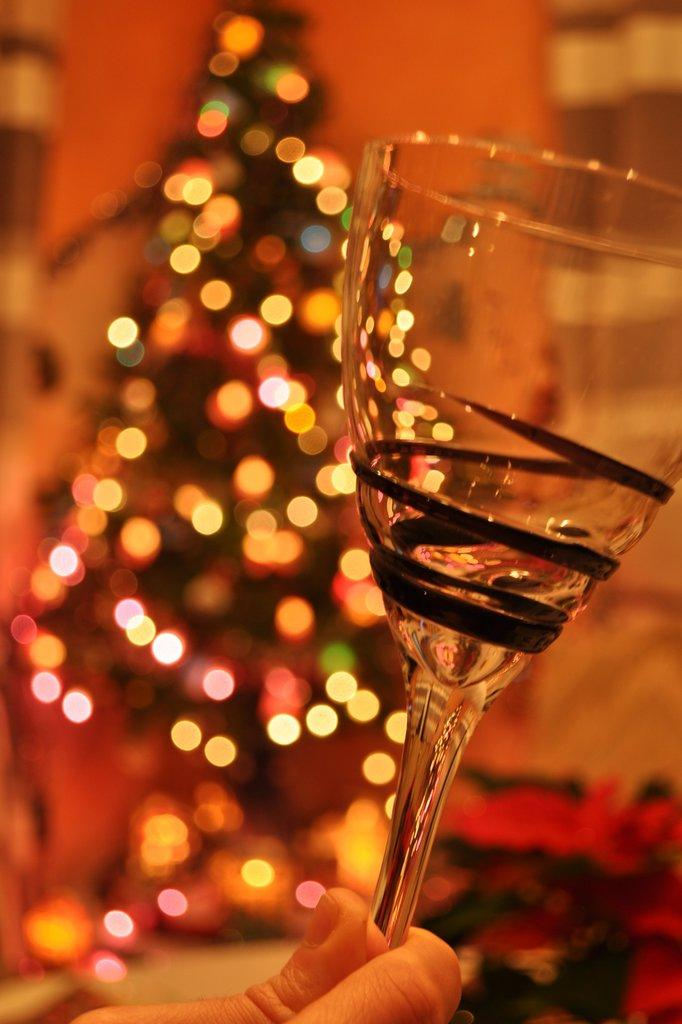What is the person's hand holding in the image? There is a person's hand holding a glass in the image. Can you describe the background of the image? The background of the image is blurry. What type of water can be seen flowing from the top of the glass in the image? There is no water visible in the image, and the glass is not shown as containing any liquid. 